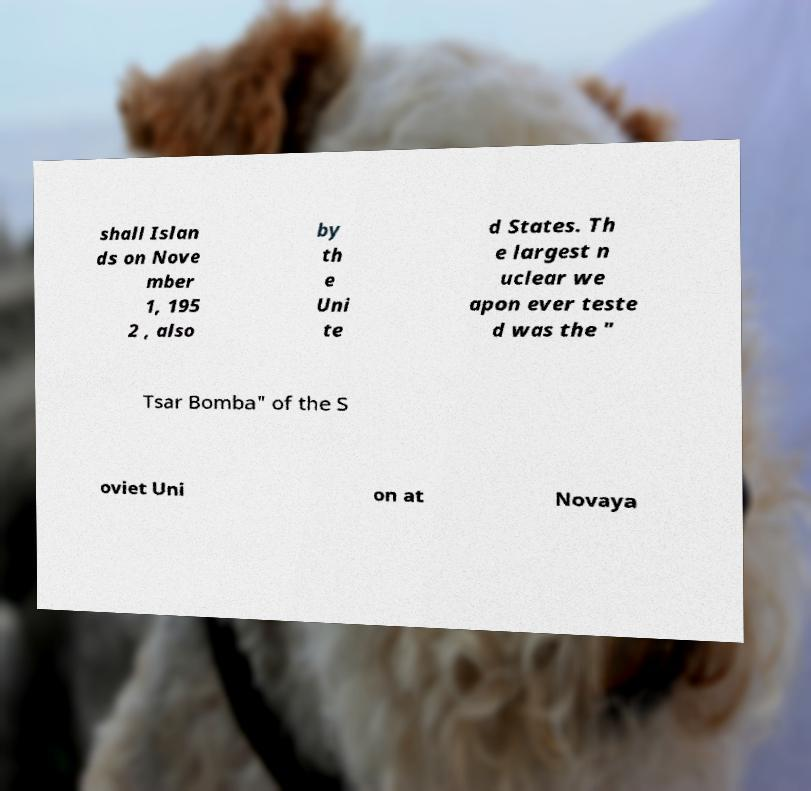Could you assist in decoding the text presented in this image and type it out clearly? shall Islan ds on Nove mber 1, 195 2 , also by th e Uni te d States. Th e largest n uclear we apon ever teste d was the " Tsar Bomba" of the S oviet Uni on at Novaya 